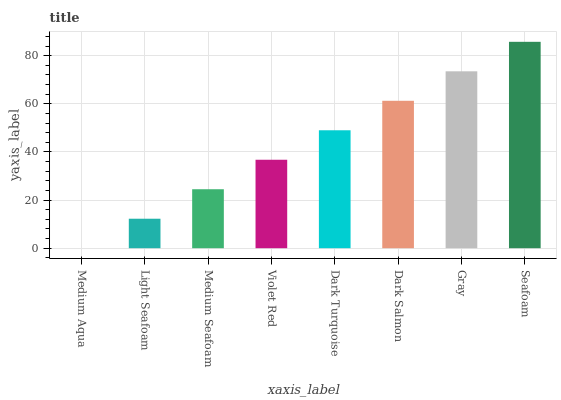Is Medium Aqua the minimum?
Answer yes or no. Yes. Is Seafoam the maximum?
Answer yes or no. Yes. Is Light Seafoam the minimum?
Answer yes or no. No. Is Light Seafoam the maximum?
Answer yes or no. No. Is Light Seafoam greater than Medium Aqua?
Answer yes or no. Yes. Is Medium Aqua less than Light Seafoam?
Answer yes or no. Yes. Is Medium Aqua greater than Light Seafoam?
Answer yes or no. No. Is Light Seafoam less than Medium Aqua?
Answer yes or no. No. Is Dark Turquoise the high median?
Answer yes or no. Yes. Is Violet Red the low median?
Answer yes or no. Yes. Is Gray the high median?
Answer yes or no. No. Is Dark Turquoise the low median?
Answer yes or no. No. 